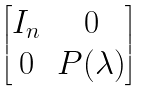Convert formula to latex. <formula><loc_0><loc_0><loc_500><loc_500>\begin{bmatrix} I _ { n } & 0 \\ 0 & P ( \lambda ) \end{bmatrix}</formula> 